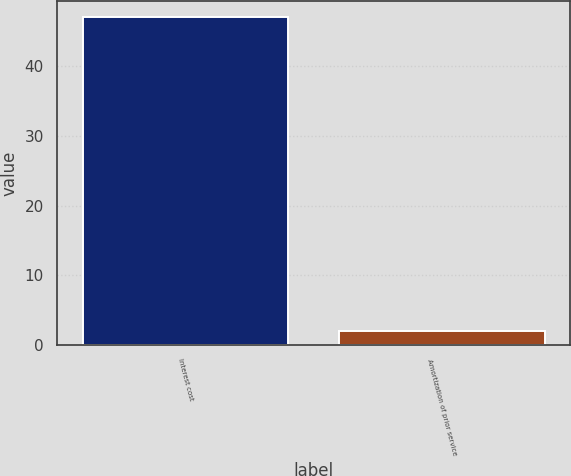<chart> <loc_0><loc_0><loc_500><loc_500><bar_chart><fcel>Interest cost<fcel>Amortization of prior service<nl><fcel>47<fcel>2<nl></chart> 